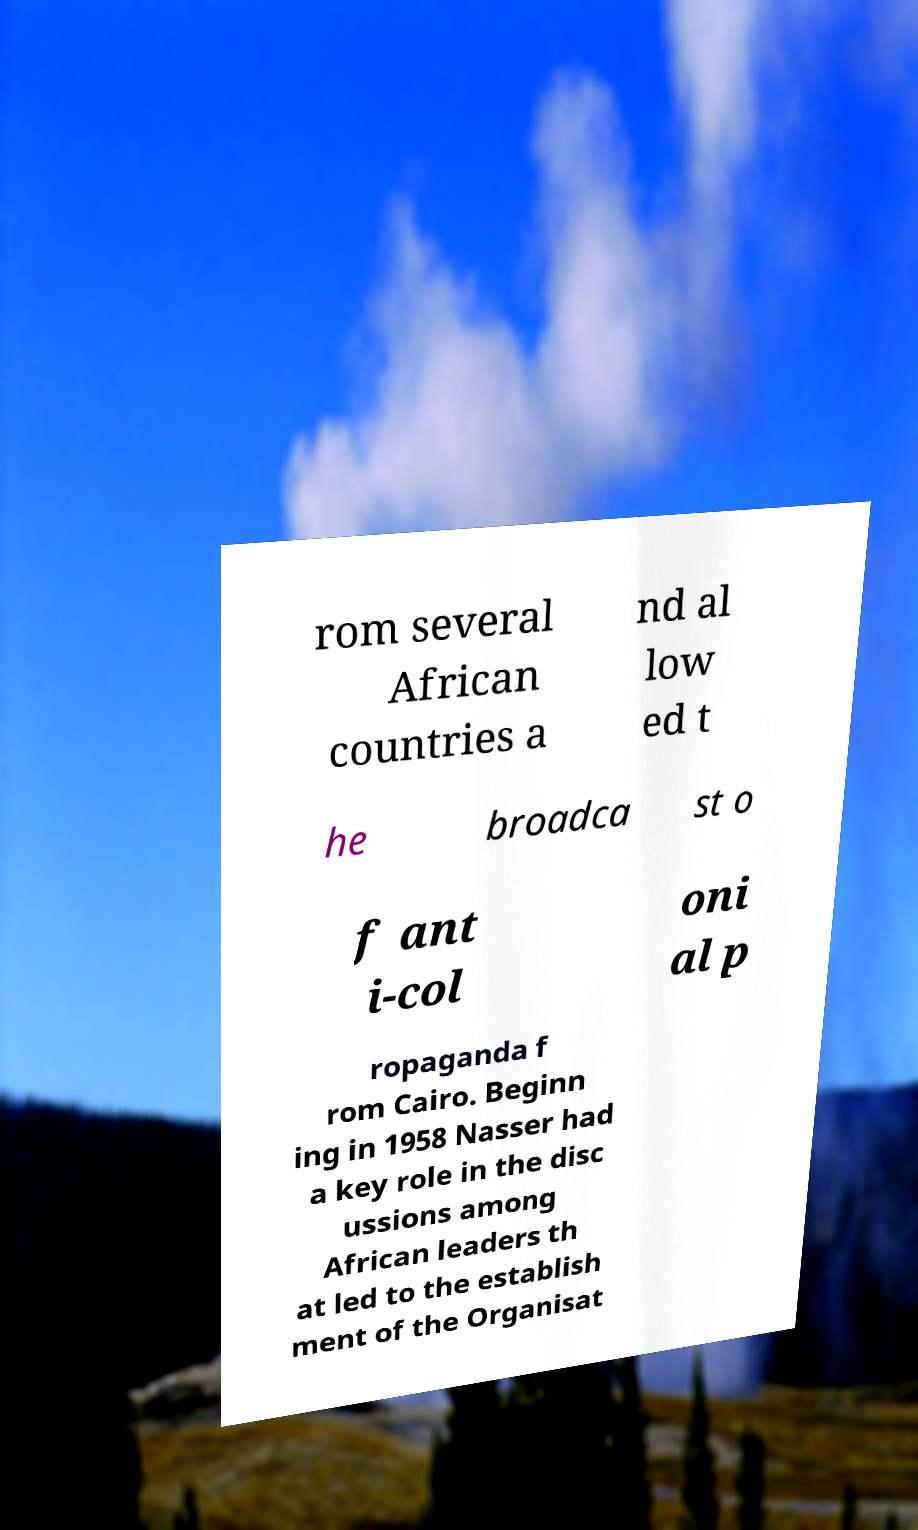Please read and relay the text visible in this image. What does it say? rom several African countries a nd al low ed t he broadca st o f ant i-col oni al p ropaganda f rom Cairo. Beginn ing in 1958 Nasser had a key role in the disc ussions among African leaders th at led to the establish ment of the Organisat 